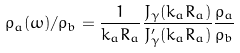<formula> <loc_0><loc_0><loc_500><loc_500>\rho _ { a } ( \omega ) / \rho _ { b } = \frac { 1 } { k _ { a } R _ { a } } \frac { J _ { \gamma } ( k _ { a } R _ { a } ) } { J ^ { \prime } _ { \gamma } ( k _ { a } R _ { a } ) } \frac { \rho _ { a } } { \rho _ { b } }</formula> 